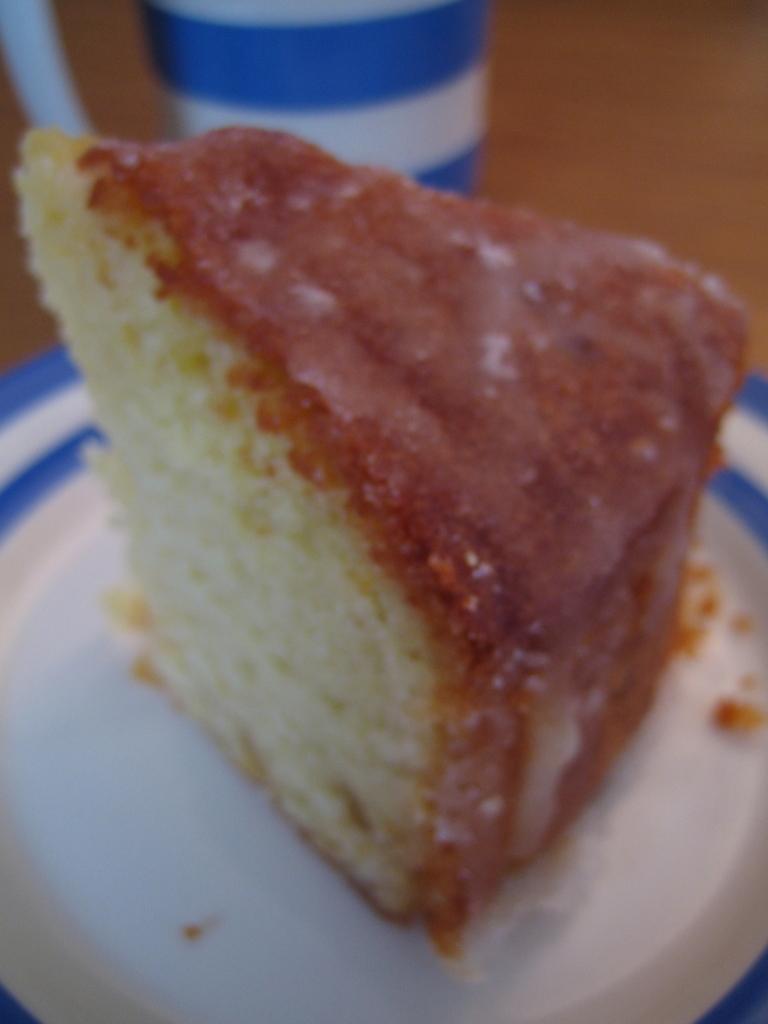Could you give a brief overview of what you see in this image? In the picture we can see a piece of cake is cut and kept on the white color plate. In the background, we can see another object which is in blue and white color. 